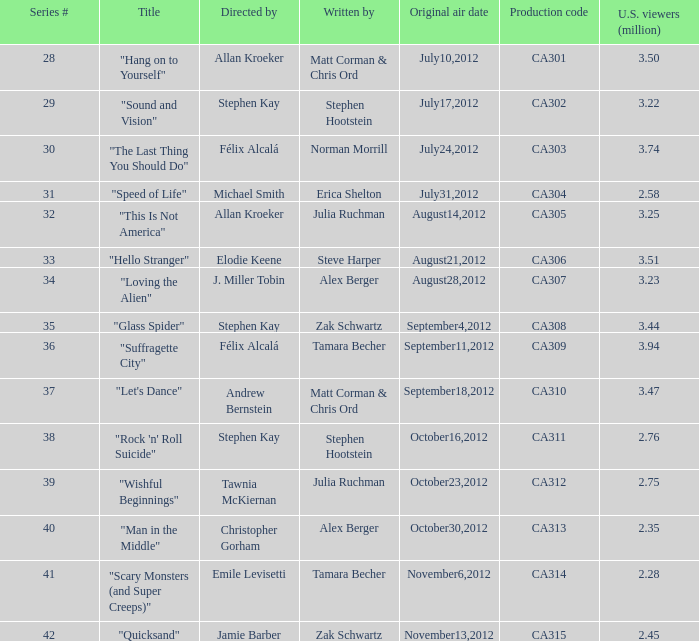Who directed the episode with production code ca303? Félix Alcalá. 